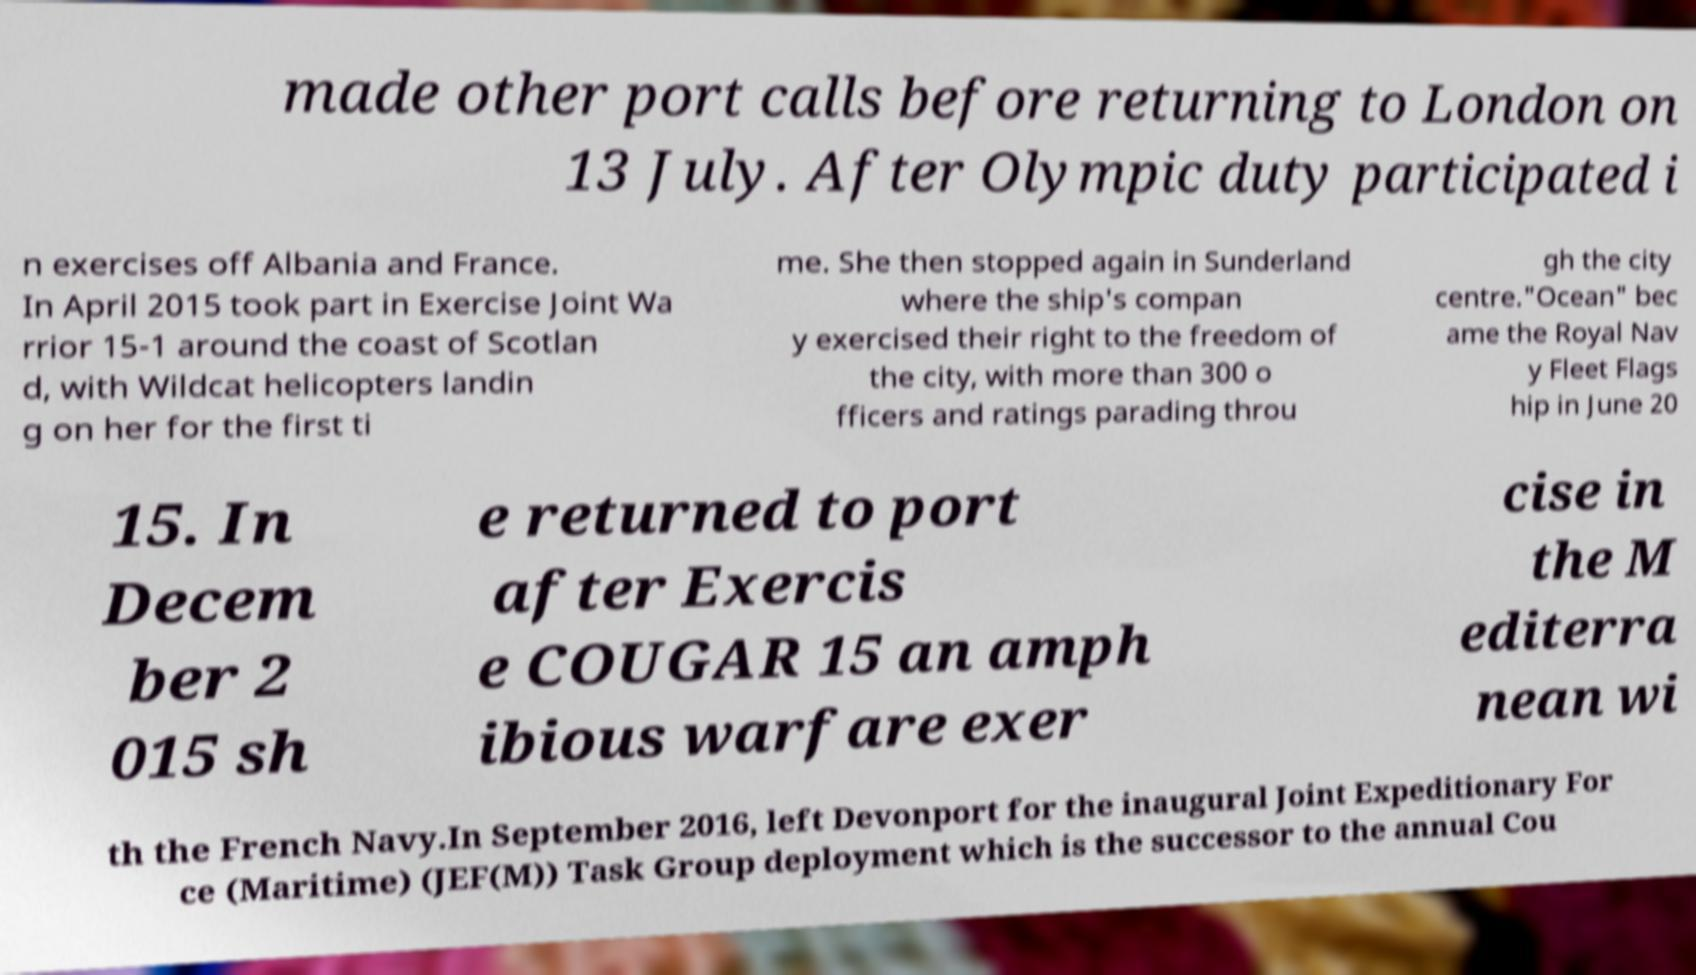I need the written content from this picture converted into text. Can you do that? made other port calls before returning to London on 13 July. After Olympic duty participated i n exercises off Albania and France. In April 2015 took part in Exercise Joint Wa rrior 15-1 around the coast of Scotlan d, with Wildcat helicopters landin g on her for the first ti me. She then stopped again in Sunderland where the ship's compan y exercised their right to the freedom of the city, with more than 300 o fficers and ratings parading throu gh the city centre."Ocean" bec ame the Royal Nav y Fleet Flags hip in June 20 15. In Decem ber 2 015 sh e returned to port after Exercis e COUGAR 15 an amph ibious warfare exer cise in the M editerra nean wi th the French Navy.In September 2016, left Devonport for the inaugural Joint Expeditionary For ce (Maritime) (JEF(M)) Task Group deployment which is the successor to the annual Cou 